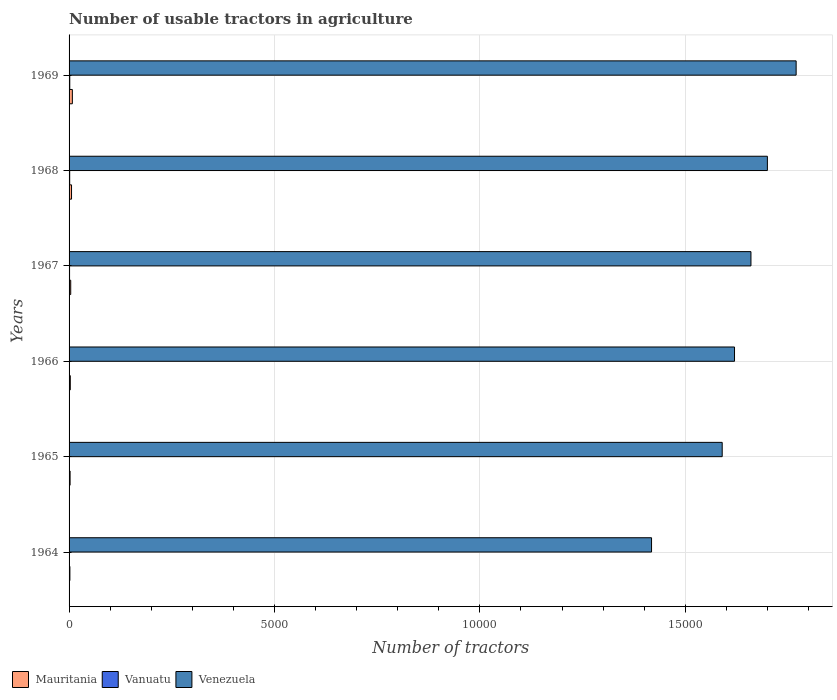How many bars are there on the 5th tick from the top?
Make the answer very short. 3. What is the label of the 3rd group of bars from the top?
Your answer should be compact. 1967. Across all years, what is the minimum number of usable tractors in agriculture in Mauritania?
Keep it short and to the point. 20. In which year was the number of usable tractors in agriculture in Venezuela maximum?
Offer a terse response. 1969. In which year was the number of usable tractors in agriculture in Vanuatu minimum?
Provide a short and direct response. 1964. What is the difference between the number of usable tractors in agriculture in Mauritania in 1966 and the number of usable tractors in agriculture in Vanuatu in 1969?
Provide a short and direct response. 13. What is the average number of usable tractors in agriculture in Mauritania per year?
Your answer should be very brief. 42.5. In the year 1969, what is the difference between the number of usable tractors in agriculture in Vanuatu and number of usable tractors in agriculture in Venezuela?
Your answer should be very brief. -1.77e+04. In how many years, is the number of usable tractors in agriculture in Vanuatu greater than 3000 ?
Your answer should be very brief. 0. What is the ratio of the number of usable tractors in agriculture in Mauritania in 1967 to that in 1969?
Provide a short and direct response. 0.5. What is the difference between the highest and the second highest number of usable tractors in agriculture in Venezuela?
Your answer should be very brief. 700. In how many years, is the number of usable tractors in agriculture in Vanuatu greater than the average number of usable tractors in agriculture in Vanuatu taken over all years?
Offer a terse response. 3. Is the sum of the number of usable tractors in agriculture in Vanuatu in 1967 and 1969 greater than the maximum number of usable tractors in agriculture in Venezuela across all years?
Offer a terse response. No. What does the 2nd bar from the top in 1965 represents?
Your answer should be very brief. Vanuatu. What does the 1st bar from the bottom in 1968 represents?
Your response must be concise. Mauritania. Are all the bars in the graph horizontal?
Your answer should be compact. Yes. How many years are there in the graph?
Offer a terse response. 6. What is the difference between two consecutive major ticks on the X-axis?
Make the answer very short. 5000. Are the values on the major ticks of X-axis written in scientific E-notation?
Give a very brief answer. No. How are the legend labels stacked?
Ensure brevity in your answer.  Horizontal. What is the title of the graph?
Provide a short and direct response. Number of usable tractors in agriculture. What is the label or title of the X-axis?
Provide a short and direct response. Number of tractors. What is the label or title of the Y-axis?
Provide a succinct answer. Years. What is the Number of tractors of Mauritania in 1964?
Give a very brief answer. 20. What is the Number of tractors of Vanuatu in 1964?
Your answer should be very brief. 3. What is the Number of tractors in Venezuela in 1964?
Make the answer very short. 1.42e+04. What is the Number of tractors in Venezuela in 1965?
Ensure brevity in your answer.  1.59e+04. What is the Number of tractors of Mauritania in 1966?
Offer a terse response. 30. What is the Number of tractors of Vanuatu in 1966?
Ensure brevity in your answer.  8. What is the Number of tractors of Venezuela in 1966?
Provide a succinct answer. 1.62e+04. What is the Number of tractors in Vanuatu in 1967?
Offer a very short reply. 12. What is the Number of tractors of Venezuela in 1967?
Your answer should be very brief. 1.66e+04. What is the Number of tractors in Vanuatu in 1968?
Keep it short and to the point. 15. What is the Number of tractors of Venezuela in 1968?
Offer a very short reply. 1.70e+04. What is the Number of tractors of Mauritania in 1969?
Ensure brevity in your answer.  80. What is the Number of tractors of Vanuatu in 1969?
Your answer should be very brief. 17. What is the Number of tractors of Venezuela in 1969?
Make the answer very short. 1.77e+04. Across all years, what is the maximum Number of tractors of Vanuatu?
Your answer should be compact. 17. Across all years, what is the maximum Number of tractors in Venezuela?
Your response must be concise. 1.77e+04. Across all years, what is the minimum Number of tractors of Vanuatu?
Your response must be concise. 3. Across all years, what is the minimum Number of tractors in Venezuela?
Your response must be concise. 1.42e+04. What is the total Number of tractors in Mauritania in the graph?
Provide a succinct answer. 255. What is the total Number of tractors in Vanuatu in the graph?
Offer a very short reply. 58. What is the total Number of tractors of Venezuela in the graph?
Provide a short and direct response. 9.76e+04. What is the difference between the Number of tractors in Mauritania in 1964 and that in 1965?
Offer a terse response. -5. What is the difference between the Number of tractors in Vanuatu in 1964 and that in 1965?
Give a very brief answer. 0. What is the difference between the Number of tractors in Venezuela in 1964 and that in 1965?
Provide a short and direct response. -1720. What is the difference between the Number of tractors of Mauritania in 1964 and that in 1966?
Your response must be concise. -10. What is the difference between the Number of tractors of Venezuela in 1964 and that in 1966?
Offer a very short reply. -2020. What is the difference between the Number of tractors in Mauritania in 1964 and that in 1967?
Provide a succinct answer. -20. What is the difference between the Number of tractors in Venezuela in 1964 and that in 1967?
Keep it short and to the point. -2420. What is the difference between the Number of tractors in Venezuela in 1964 and that in 1968?
Ensure brevity in your answer.  -2820. What is the difference between the Number of tractors in Mauritania in 1964 and that in 1969?
Your response must be concise. -60. What is the difference between the Number of tractors in Venezuela in 1964 and that in 1969?
Make the answer very short. -3520. What is the difference between the Number of tractors in Venezuela in 1965 and that in 1966?
Provide a succinct answer. -300. What is the difference between the Number of tractors in Vanuatu in 1965 and that in 1967?
Provide a short and direct response. -9. What is the difference between the Number of tractors in Venezuela in 1965 and that in 1967?
Offer a very short reply. -700. What is the difference between the Number of tractors in Mauritania in 1965 and that in 1968?
Your response must be concise. -35. What is the difference between the Number of tractors of Vanuatu in 1965 and that in 1968?
Offer a terse response. -12. What is the difference between the Number of tractors in Venezuela in 1965 and that in 1968?
Your response must be concise. -1100. What is the difference between the Number of tractors in Mauritania in 1965 and that in 1969?
Ensure brevity in your answer.  -55. What is the difference between the Number of tractors in Vanuatu in 1965 and that in 1969?
Ensure brevity in your answer.  -14. What is the difference between the Number of tractors in Venezuela in 1965 and that in 1969?
Make the answer very short. -1800. What is the difference between the Number of tractors of Mauritania in 1966 and that in 1967?
Make the answer very short. -10. What is the difference between the Number of tractors of Venezuela in 1966 and that in 1967?
Make the answer very short. -400. What is the difference between the Number of tractors in Vanuatu in 1966 and that in 1968?
Offer a terse response. -7. What is the difference between the Number of tractors of Venezuela in 1966 and that in 1968?
Provide a succinct answer. -800. What is the difference between the Number of tractors of Vanuatu in 1966 and that in 1969?
Your response must be concise. -9. What is the difference between the Number of tractors of Venezuela in 1966 and that in 1969?
Provide a short and direct response. -1500. What is the difference between the Number of tractors in Venezuela in 1967 and that in 1968?
Provide a succinct answer. -400. What is the difference between the Number of tractors of Mauritania in 1967 and that in 1969?
Your answer should be compact. -40. What is the difference between the Number of tractors of Venezuela in 1967 and that in 1969?
Your answer should be very brief. -1100. What is the difference between the Number of tractors of Vanuatu in 1968 and that in 1969?
Keep it short and to the point. -2. What is the difference between the Number of tractors in Venezuela in 1968 and that in 1969?
Your answer should be very brief. -700. What is the difference between the Number of tractors of Mauritania in 1964 and the Number of tractors of Venezuela in 1965?
Your answer should be compact. -1.59e+04. What is the difference between the Number of tractors in Vanuatu in 1964 and the Number of tractors in Venezuela in 1965?
Offer a very short reply. -1.59e+04. What is the difference between the Number of tractors in Mauritania in 1964 and the Number of tractors in Vanuatu in 1966?
Make the answer very short. 12. What is the difference between the Number of tractors in Mauritania in 1964 and the Number of tractors in Venezuela in 1966?
Provide a short and direct response. -1.62e+04. What is the difference between the Number of tractors in Vanuatu in 1964 and the Number of tractors in Venezuela in 1966?
Provide a succinct answer. -1.62e+04. What is the difference between the Number of tractors of Mauritania in 1964 and the Number of tractors of Vanuatu in 1967?
Your answer should be very brief. 8. What is the difference between the Number of tractors of Mauritania in 1964 and the Number of tractors of Venezuela in 1967?
Your response must be concise. -1.66e+04. What is the difference between the Number of tractors in Vanuatu in 1964 and the Number of tractors in Venezuela in 1967?
Your answer should be compact. -1.66e+04. What is the difference between the Number of tractors of Mauritania in 1964 and the Number of tractors of Vanuatu in 1968?
Your response must be concise. 5. What is the difference between the Number of tractors in Mauritania in 1964 and the Number of tractors in Venezuela in 1968?
Give a very brief answer. -1.70e+04. What is the difference between the Number of tractors in Vanuatu in 1964 and the Number of tractors in Venezuela in 1968?
Your response must be concise. -1.70e+04. What is the difference between the Number of tractors of Mauritania in 1964 and the Number of tractors of Vanuatu in 1969?
Your answer should be compact. 3. What is the difference between the Number of tractors in Mauritania in 1964 and the Number of tractors in Venezuela in 1969?
Ensure brevity in your answer.  -1.77e+04. What is the difference between the Number of tractors in Vanuatu in 1964 and the Number of tractors in Venezuela in 1969?
Make the answer very short. -1.77e+04. What is the difference between the Number of tractors of Mauritania in 1965 and the Number of tractors of Vanuatu in 1966?
Offer a terse response. 17. What is the difference between the Number of tractors of Mauritania in 1965 and the Number of tractors of Venezuela in 1966?
Provide a short and direct response. -1.62e+04. What is the difference between the Number of tractors in Vanuatu in 1965 and the Number of tractors in Venezuela in 1966?
Provide a short and direct response. -1.62e+04. What is the difference between the Number of tractors in Mauritania in 1965 and the Number of tractors in Venezuela in 1967?
Keep it short and to the point. -1.66e+04. What is the difference between the Number of tractors in Vanuatu in 1965 and the Number of tractors in Venezuela in 1967?
Your answer should be compact. -1.66e+04. What is the difference between the Number of tractors of Mauritania in 1965 and the Number of tractors of Venezuela in 1968?
Your response must be concise. -1.70e+04. What is the difference between the Number of tractors of Vanuatu in 1965 and the Number of tractors of Venezuela in 1968?
Your answer should be very brief. -1.70e+04. What is the difference between the Number of tractors of Mauritania in 1965 and the Number of tractors of Vanuatu in 1969?
Keep it short and to the point. 8. What is the difference between the Number of tractors in Mauritania in 1965 and the Number of tractors in Venezuela in 1969?
Ensure brevity in your answer.  -1.77e+04. What is the difference between the Number of tractors in Vanuatu in 1965 and the Number of tractors in Venezuela in 1969?
Your answer should be compact. -1.77e+04. What is the difference between the Number of tractors in Mauritania in 1966 and the Number of tractors in Venezuela in 1967?
Offer a terse response. -1.66e+04. What is the difference between the Number of tractors in Vanuatu in 1966 and the Number of tractors in Venezuela in 1967?
Make the answer very short. -1.66e+04. What is the difference between the Number of tractors of Mauritania in 1966 and the Number of tractors of Vanuatu in 1968?
Your answer should be very brief. 15. What is the difference between the Number of tractors in Mauritania in 1966 and the Number of tractors in Venezuela in 1968?
Provide a succinct answer. -1.70e+04. What is the difference between the Number of tractors in Vanuatu in 1966 and the Number of tractors in Venezuela in 1968?
Provide a short and direct response. -1.70e+04. What is the difference between the Number of tractors of Mauritania in 1966 and the Number of tractors of Venezuela in 1969?
Give a very brief answer. -1.77e+04. What is the difference between the Number of tractors in Vanuatu in 1966 and the Number of tractors in Venezuela in 1969?
Offer a very short reply. -1.77e+04. What is the difference between the Number of tractors of Mauritania in 1967 and the Number of tractors of Vanuatu in 1968?
Offer a very short reply. 25. What is the difference between the Number of tractors of Mauritania in 1967 and the Number of tractors of Venezuela in 1968?
Offer a terse response. -1.70e+04. What is the difference between the Number of tractors in Vanuatu in 1967 and the Number of tractors in Venezuela in 1968?
Provide a succinct answer. -1.70e+04. What is the difference between the Number of tractors in Mauritania in 1967 and the Number of tractors in Venezuela in 1969?
Provide a short and direct response. -1.77e+04. What is the difference between the Number of tractors in Vanuatu in 1967 and the Number of tractors in Venezuela in 1969?
Provide a succinct answer. -1.77e+04. What is the difference between the Number of tractors of Mauritania in 1968 and the Number of tractors of Vanuatu in 1969?
Ensure brevity in your answer.  43. What is the difference between the Number of tractors in Mauritania in 1968 and the Number of tractors in Venezuela in 1969?
Offer a terse response. -1.76e+04. What is the difference between the Number of tractors of Vanuatu in 1968 and the Number of tractors of Venezuela in 1969?
Your response must be concise. -1.77e+04. What is the average Number of tractors of Mauritania per year?
Make the answer very short. 42.5. What is the average Number of tractors of Vanuatu per year?
Keep it short and to the point. 9.67. What is the average Number of tractors in Venezuela per year?
Provide a succinct answer. 1.63e+04. In the year 1964, what is the difference between the Number of tractors of Mauritania and Number of tractors of Vanuatu?
Make the answer very short. 17. In the year 1964, what is the difference between the Number of tractors in Mauritania and Number of tractors in Venezuela?
Ensure brevity in your answer.  -1.42e+04. In the year 1964, what is the difference between the Number of tractors in Vanuatu and Number of tractors in Venezuela?
Keep it short and to the point. -1.42e+04. In the year 1965, what is the difference between the Number of tractors in Mauritania and Number of tractors in Venezuela?
Make the answer very short. -1.59e+04. In the year 1965, what is the difference between the Number of tractors in Vanuatu and Number of tractors in Venezuela?
Make the answer very short. -1.59e+04. In the year 1966, what is the difference between the Number of tractors in Mauritania and Number of tractors in Venezuela?
Ensure brevity in your answer.  -1.62e+04. In the year 1966, what is the difference between the Number of tractors of Vanuatu and Number of tractors of Venezuela?
Make the answer very short. -1.62e+04. In the year 1967, what is the difference between the Number of tractors of Mauritania and Number of tractors of Vanuatu?
Offer a very short reply. 28. In the year 1967, what is the difference between the Number of tractors in Mauritania and Number of tractors in Venezuela?
Ensure brevity in your answer.  -1.66e+04. In the year 1967, what is the difference between the Number of tractors in Vanuatu and Number of tractors in Venezuela?
Provide a succinct answer. -1.66e+04. In the year 1968, what is the difference between the Number of tractors of Mauritania and Number of tractors of Vanuatu?
Provide a short and direct response. 45. In the year 1968, what is the difference between the Number of tractors in Mauritania and Number of tractors in Venezuela?
Your response must be concise. -1.69e+04. In the year 1968, what is the difference between the Number of tractors in Vanuatu and Number of tractors in Venezuela?
Offer a terse response. -1.70e+04. In the year 1969, what is the difference between the Number of tractors of Mauritania and Number of tractors of Vanuatu?
Provide a succinct answer. 63. In the year 1969, what is the difference between the Number of tractors in Mauritania and Number of tractors in Venezuela?
Make the answer very short. -1.76e+04. In the year 1969, what is the difference between the Number of tractors in Vanuatu and Number of tractors in Venezuela?
Ensure brevity in your answer.  -1.77e+04. What is the ratio of the Number of tractors of Vanuatu in 1964 to that in 1965?
Your response must be concise. 1. What is the ratio of the Number of tractors in Venezuela in 1964 to that in 1965?
Ensure brevity in your answer.  0.89. What is the ratio of the Number of tractors in Mauritania in 1964 to that in 1966?
Offer a very short reply. 0.67. What is the ratio of the Number of tractors of Venezuela in 1964 to that in 1966?
Make the answer very short. 0.88. What is the ratio of the Number of tractors in Vanuatu in 1964 to that in 1967?
Your answer should be very brief. 0.25. What is the ratio of the Number of tractors in Venezuela in 1964 to that in 1967?
Keep it short and to the point. 0.85. What is the ratio of the Number of tractors in Vanuatu in 1964 to that in 1968?
Your response must be concise. 0.2. What is the ratio of the Number of tractors in Venezuela in 1964 to that in 1968?
Offer a very short reply. 0.83. What is the ratio of the Number of tractors in Vanuatu in 1964 to that in 1969?
Your answer should be very brief. 0.18. What is the ratio of the Number of tractors of Venezuela in 1964 to that in 1969?
Make the answer very short. 0.8. What is the ratio of the Number of tractors of Vanuatu in 1965 to that in 1966?
Ensure brevity in your answer.  0.38. What is the ratio of the Number of tractors of Venezuela in 1965 to that in 1966?
Provide a short and direct response. 0.98. What is the ratio of the Number of tractors of Mauritania in 1965 to that in 1967?
Provide a succinct answer. 0.62. What is the ratio of the Number of tractors in Vanuatu in 1965 to that in 1967?
Make the answer very short. 0.25. What is the ratio of the Number of tractors of Venezuela in 1965 to that in 1967?
Ensure brevity in your answer.  0.96. What is the ratio of the Number of tractors in Mauritania in 1965 to that in 1968?
Give a very brief answer. 0.42. What is the ratio of the Number of tractors of Vanuatu in 1965 to that in 1968?
Keep it short and to the point. 0.2. What is the ratio of the Number of tractors in Venezuela in 1965 to that in 1968?
Offer a terse response. 0.94. What is the ratio of the Number of tractors of Mauritania in 1965 to that in 1969?
Offer a terse response. 0.31. What is the ratio of the Number of tractors of Vanuatu in 1965 to that in 1969?
Make the answer very short. 0.18. What is the ratio of the Number of tractors of Venezuela in 1965 to that in 1969?
Your response must be concise. 0.9. What is the ratio of the Number of tractors of Vanuatu in 1966 to that in 1967?
Ensure brevity in your answer.  0.67. What is the ratio of the Number of tractors in Venezuela in 1966 to that in 1967?
Your response must be concise. 0.98. What is the ratio of the Number of tractors of Mauritania in 1966 to that in 1968?
Give a very brief answer. 0.5. What is the ratio of the Number of tractors in Vanuatu in 1966 to that in 1968?
Your answer should be compact. 0.53. What is the ratio of the Number of tractors of Venezuela in 1966 to that in 1968?
Provide a short and direct response. 0.95. What is the ratio of the Number of tractors in Vanuatu in 1966 to that in 1969?
Give a very brief answer. 0.47. What is the ratio of the Number of tractors of Venezuela in 1966 to that in 1969?
Your response must be concise. 0.92. What is the ratio of the Number of tractors of Mauritania in 1967 to that in 1968?
Offer a very short reply. 0.67. What is the ratio of the Number of tractors in Vanuatu in 1967 to that in 1968?
Provide a short and direct response. 0.8. What is the ratio of the Number of tractors of Venezuela in 1967 to that in 1968?
Your answer should be compact. 0.98. What is the ratio of the Number of tractors of Mauritania in 1967 to that in 1969?
Give a very brief answer. 0.5. What is the ratio of the Number of tractors of Vanuatu in 1967 to that in 1969?
Give a very brief answer. 0.71. What is the ratio of the Number of tractors of Venezuela in 1967 to that in 1969?
Provide a short and direct response. 0.94. What is the ratio of the Number of tractors in Mauritania in 1968 to that in 1969?
Provide a succinct answer. 0.75. What is the ratio of the Number of tractors of Vanuatu in 1968 to that in 1969?
Offer a very short reply. 0.88. What is the ratio of the Number of tractors in Venezuela in 1968 to that in 1969?
Provide a succinct answer. 0.96. What is the difference between the highest and the second highest Number of tractors in Venezuela?
Provide a short and direct response. 700. What is the difference between the highest and the lowest Number of tractors in Vanuatu?
Keep it short and to the point. 14. What is the difference between the highest and the lowest Number of tractors in Venezuela?
Offer a very short reply. 3520. 